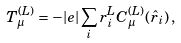Convert formula to latex. <formula><loc_0><loc_0><loc_500><loc_500>T _ { \mu } ^ { ( L ) } = - | e | \sum _ { i } r _ { i } ^ { L } C _ { \mu } ^ { ( L ) } ( \hat { r } _ { i } ) \, ,</formula> 